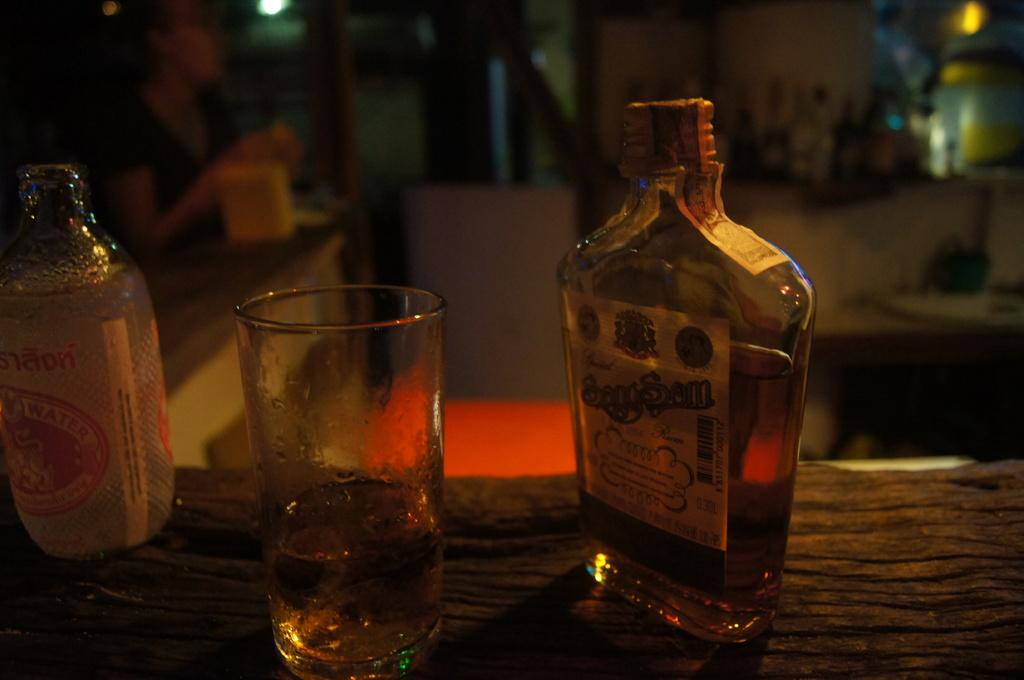<image>
Give a short and clear explanation of the subsequent image. Bottle of Sangsom alcohol next to a cup of beer. 